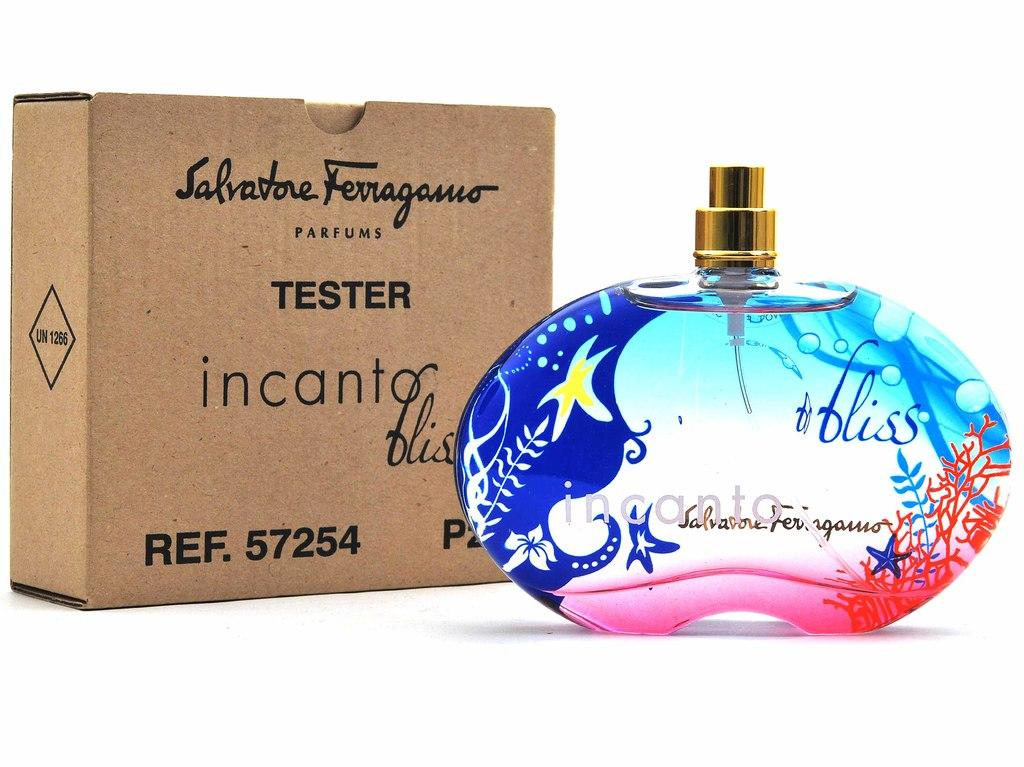<image>
Share a concise interpretation of the image provided. The incanto bliss perfume bottle is decorated with starfish , ferns and coral. 